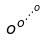Convert formula to latex. <formula><loc_0><loc_0><loc_500><loc_500>o ^ { o ^ { \cdot ^ { \cdot ^ { \cdot ^ { o } } } } }</formula> 